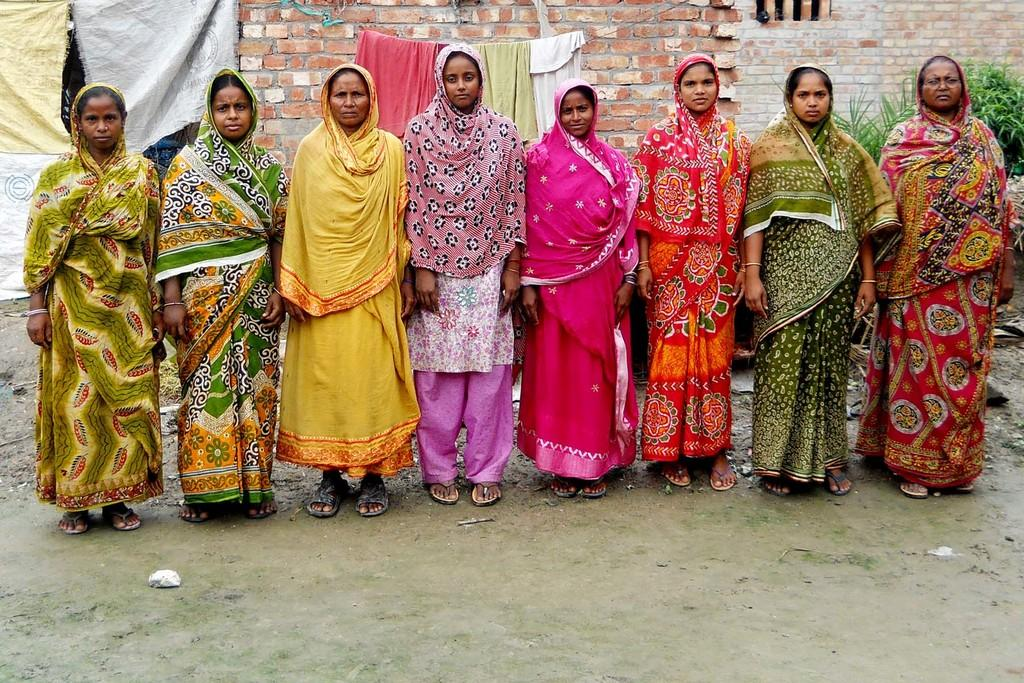What are the women in the image doing? The women in the image are standing in a queue. What can be seen in the background of the image? There is a brick wall in the background of the image. What else is visible in the image besides the women and the brick wall? There are clothes on a rope in the image. What type of thread is being used to hold the mountain in the image? There is no mountain present in the image, and therefore no thread is being used to hold it. 